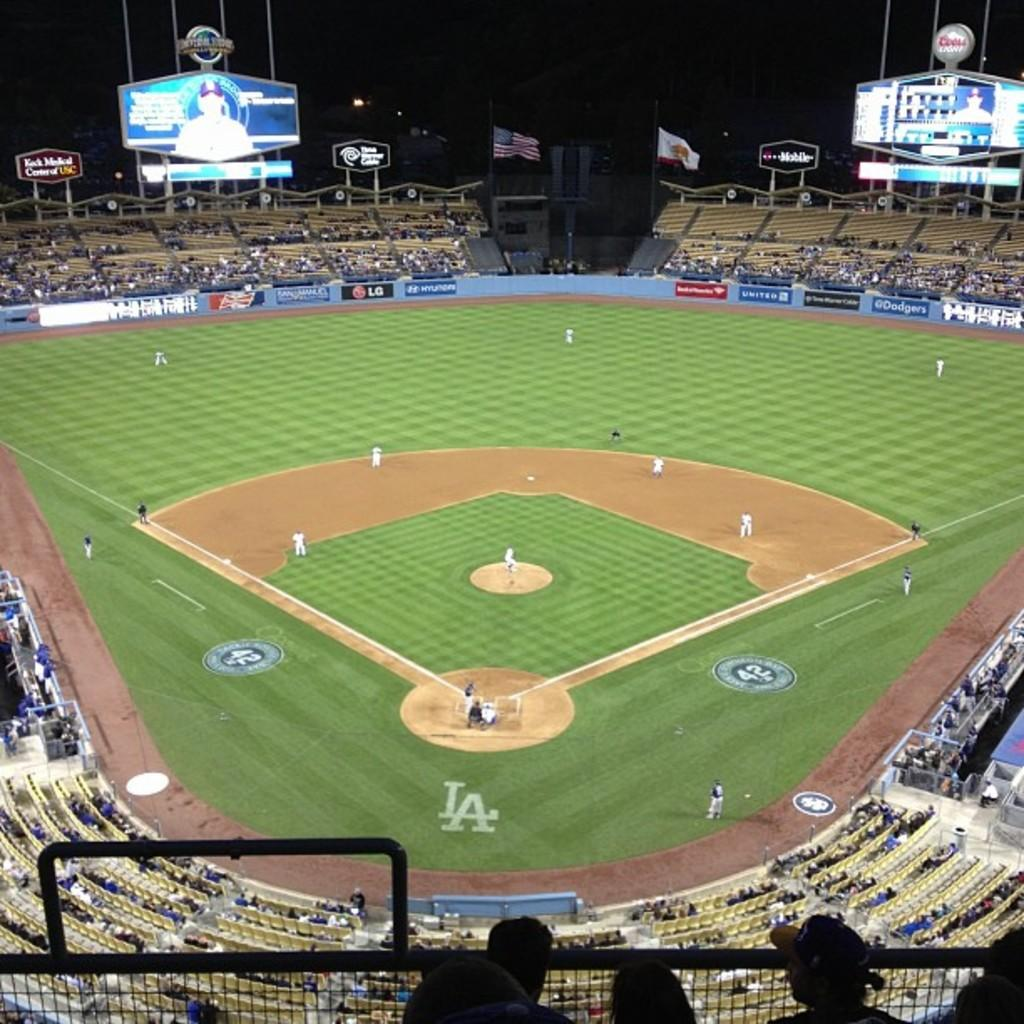<image>
Summarize the visual content of the image. A packed baseball stadium with the LA logo behind the pitchers mound. 